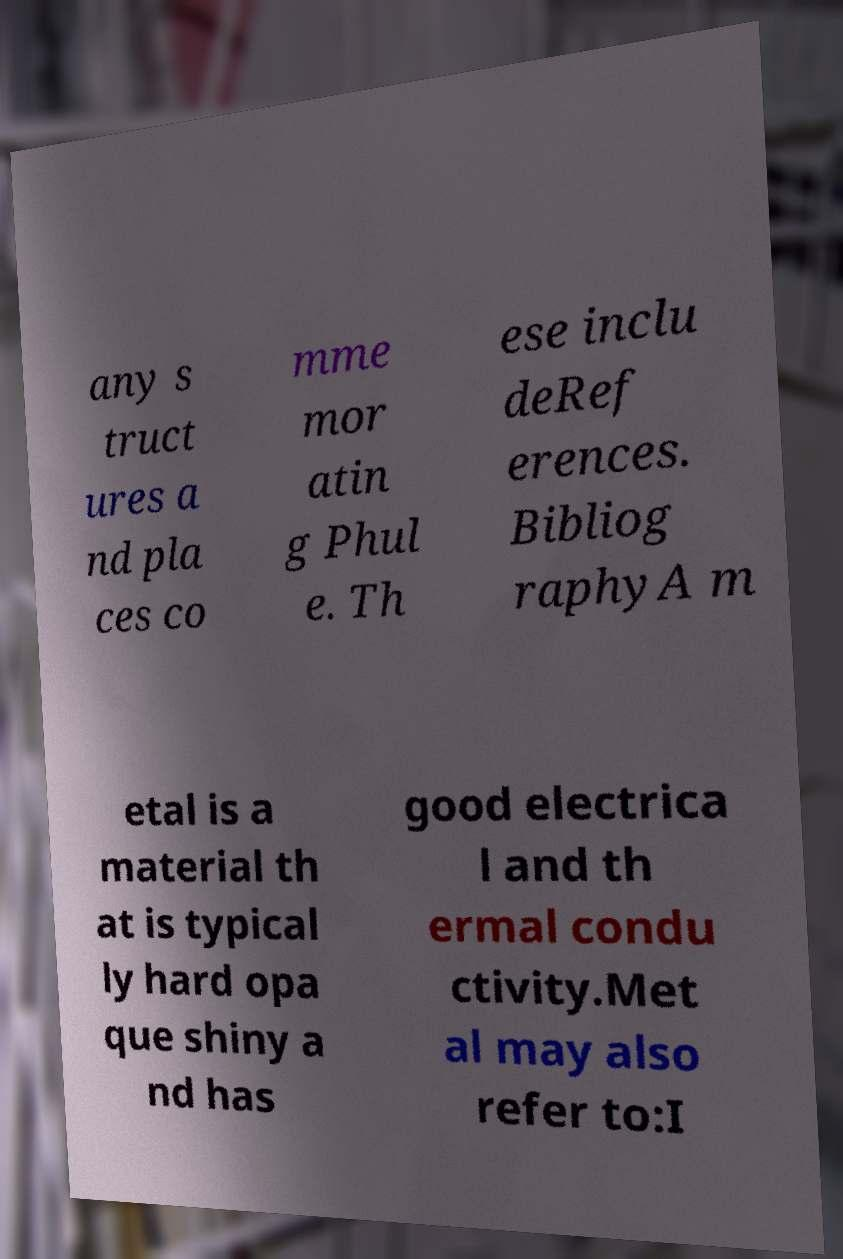For documentation purposes, I need the text within this image transcribed. Could you provide that? any s truct ures a nd pla ces co mme mor atin g Phul e. Th ese inclu deRef erences. Bibliog raphyA m etal is a material th at is typical ly hard opa que shiny a nd has good electrica l and th ermal condu ctivity.Met al may also refer to:I 